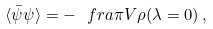Convert formula to latex. <formula><loc_0><loc_0><loc_500><loc_500>\langle \bar { \psi } \psi \rangle = - \ f r a { \pi } { V } \rho ( \lambda = 0 ) \, ,</formula> 